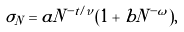<formula> <loc_0><loc_0><loc_500><loc_500>\sigma _ { N } = a N ^ { - t / \nu } ( 1 + b N ^ { - \omega } ) ,</formula> 